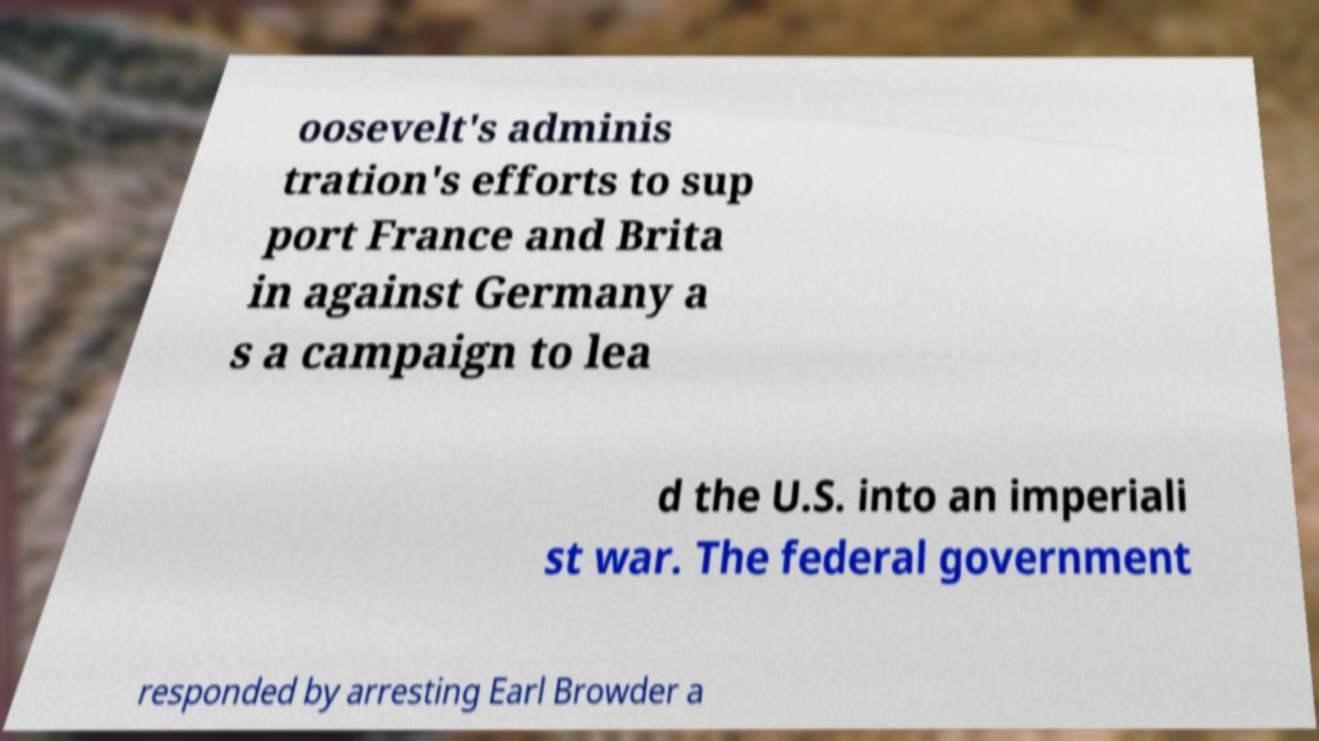Could you extract and type out the text from this image? oosevelt's adminis tration's efforts to sup port France and Brita in against Germany a s a campaign to lea d the U.S. into an imperiali st war. The federal government responded by arresting Earl Browder a 